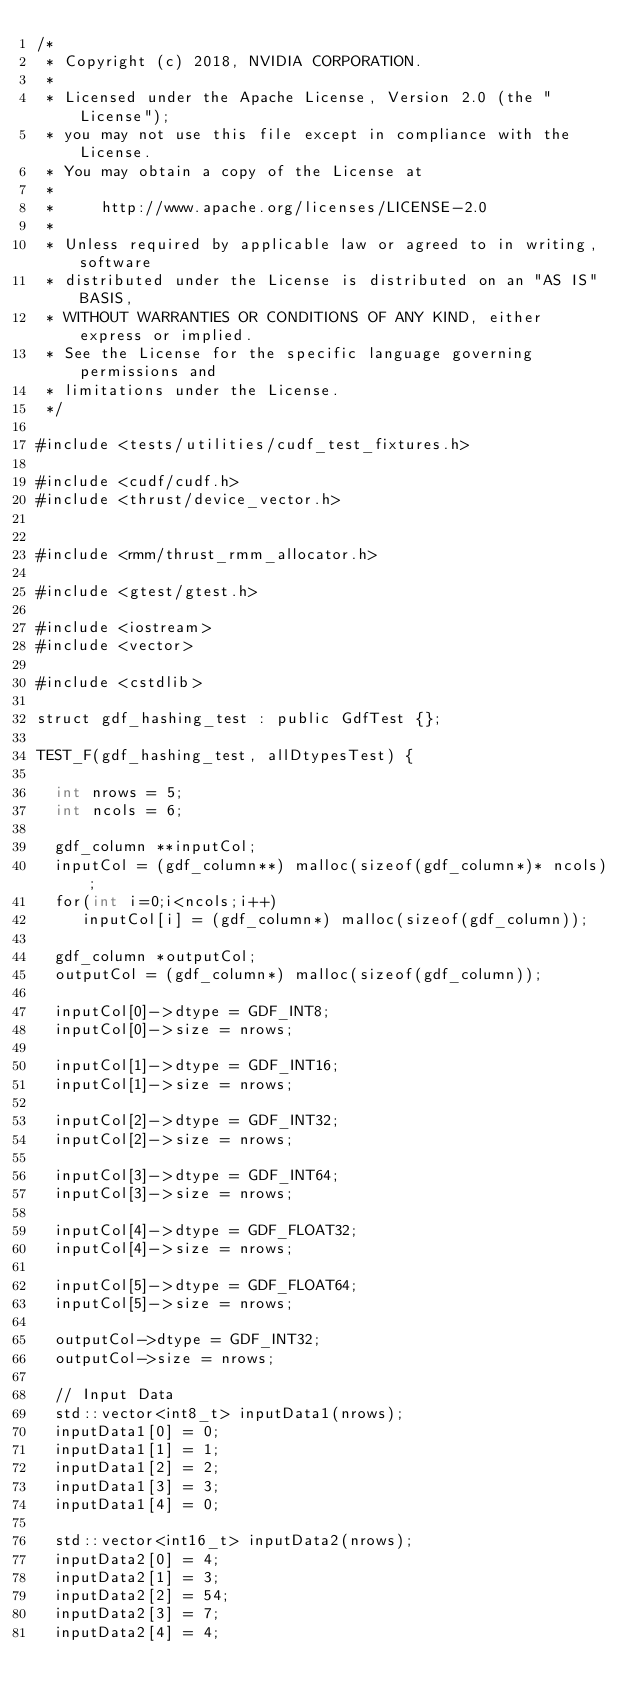<code> <loc_0><loc_0><loc_500><loc_500><_Cuda_>/*
 * Copyright (c) 2018, NVIDIA CORPORATION.
 *
 * Licensed under the Apache License, Version 2.0 (the "License");
 * you may not use this file except in compliance with the License.
 * You may obtain a copy of the License at
 *
 *     http://www.apache.org/licenses/LICENSE-2.0
 *
 * Unless required by applicable law or agreed to in writing, software
 * distributed under the License is distributed on an "AS IS" BASIS,
 * WITHOUT WARRANTIES OR CONDITIONS OF ANY KIND, either express or implied.
 * See the License for the specific language governing permissions and
 * limitations under the License.
 */

#include <tests/utilities/cudf_test_fixtures.h>

#include <cudf/cudf.h>
#include <thrust/device_vector.h>


#include <rmm/thrust_rmm_allocator.h>

#include <gtest/gtest.h>

#include <iostream>
#include <vector>

#include <cstdlib>

struct gdf_hashing_test : public GdfTest {};

TEST_F(gdf_hashing_test, allDtypesTest) {

  int nrows = 5;
  int ncols = 6;

  gdf_column **inputCol;
  inputCol = (gdf_column**) malloc(sizeof(gdf_column*)* ncols);
  for(int i=0;i<ncols;i++)
  	 inputCol[i] = (gdf_column*) malloc(sizeof(gdf_column));

  gdf_column *outputCol;
  outputCol = (gdf_column*) malloc(sizeof(gdf_column));

  inputCol[0]->dtype = GDF_INT8;
  inputCol[0]->size = nrows;

  inputCol[1]->dtype = GDF_INT16;
  inputCol[1]->size = nrows;

  inputCol[2]->dtype = GDF_INT32;
  inputCol[2]->size = nrows;

  inputCol[3]->dtype = GDF_INT64;
  inputCol[3]->size = nrows;

  inputCol[4]->dtype = GDF_FLOAT32;
  inputCol[4]->size = nrows;

  inputCol[5]->dtype = GDF_FLOAT64;
  inputCol[5]->size = nrows;

  outputCol->dtype = GDF_INT32;
  outputCol->size = nrows;

  // Input Data
  std::vector<int8_t> inputData1(nrows);
  inputData1[0] = 0;
  inputData1[1] = 1;
  inputData1[2] = 2;
  inputData1[3] = 3;
  inputData1[4] = 0;

  std::vector<int16_t> inputData2(nrows);
  inputData2[0] = 4;
  inputData2[1] = 3;
  inputData2[2] = 54;
  inputData2[3] = 7;
  inputData2[4] = 4;
</code> 